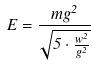<formula> <loc_0><loc_0><loc_500><loc_500>E = \frac { m g ^ { 2 } } { \sqrt { 5 \cdot \frac { w ^ { 2 } } { g ^ { 2 } } } }</formula> 